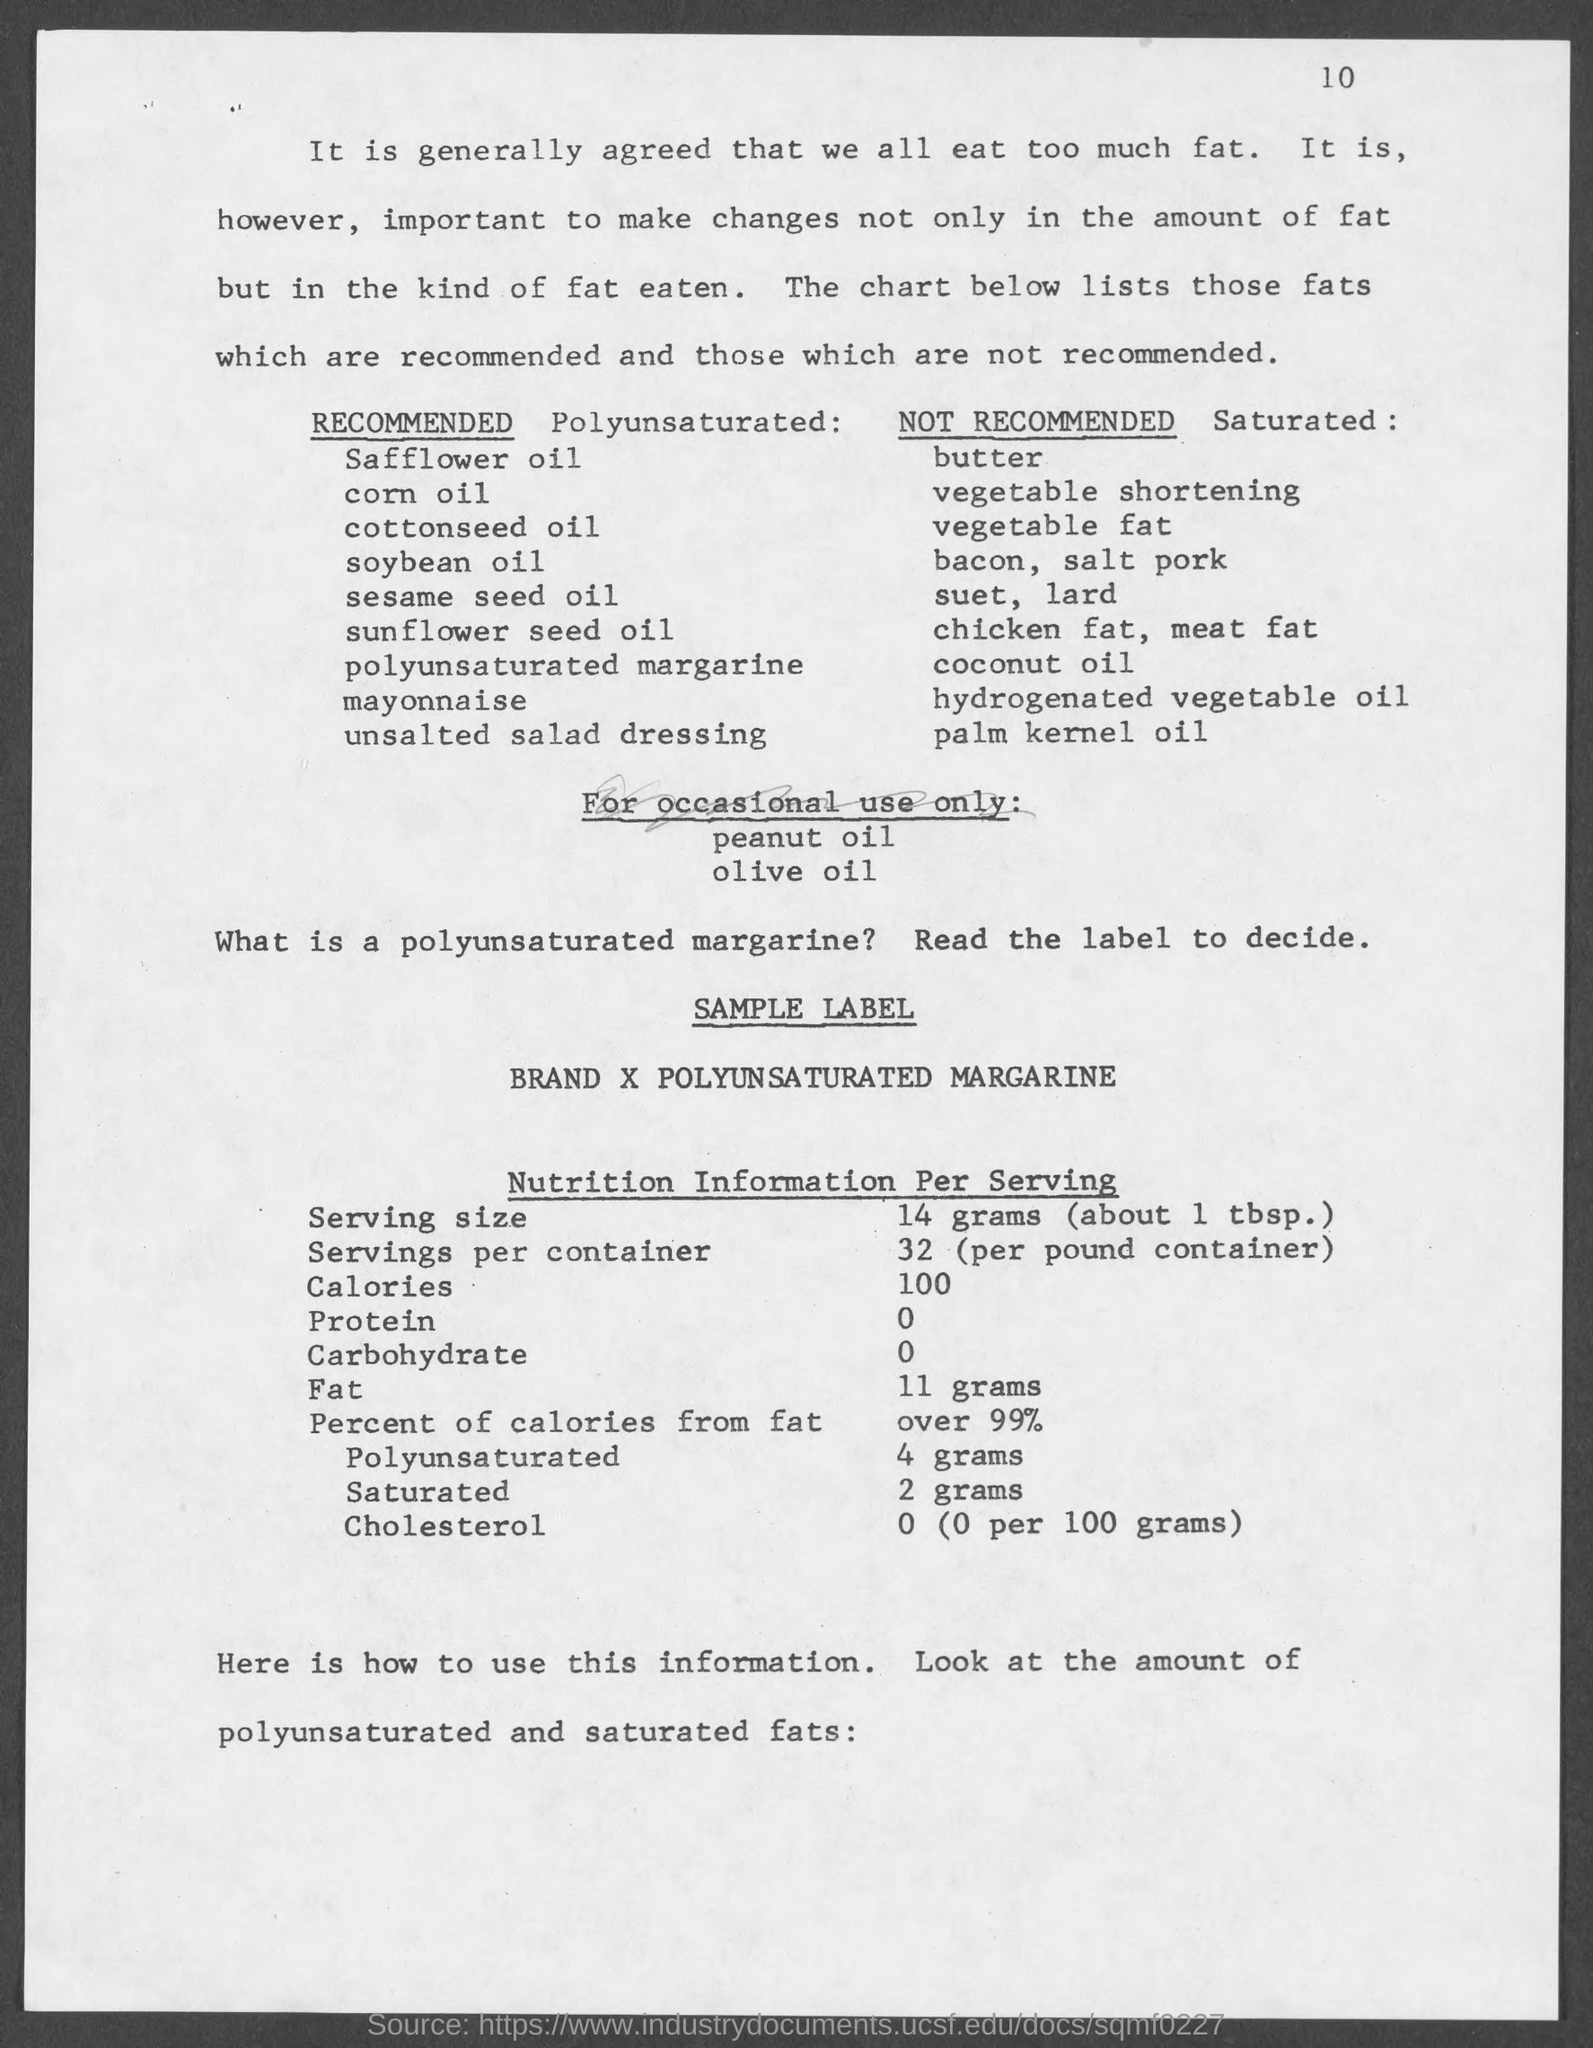Give some essential details in this illustration. The page number at the top of the page is 10. 